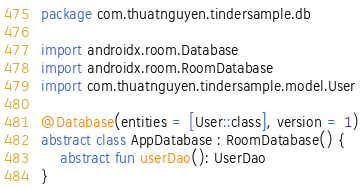<code> <loc_0><loc_0><loc_500><loc_500><_Kotlin_>package com.thuatnguyen.tindersample.db

import androidx.room.Database
import androidx.room.RoomDatabase
import com.thuatnguyen.tindersample.model.User

@Database(entities = [User::class], version = 1)
abstract class AppDatabase : RoomDatabase() {
    abstract fun userDao(): UserDao
}</code> 